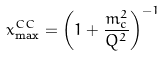Convert formula to latex. <formula><loc_0><loc_0><loc_500><loc_500>x _ { \max } ^ { C C } = \left ( 1 + \frac { m _ { c } ^ { 2 } } { Q ^ { 2 } } \right ) ^ { - 1 }</formula> 